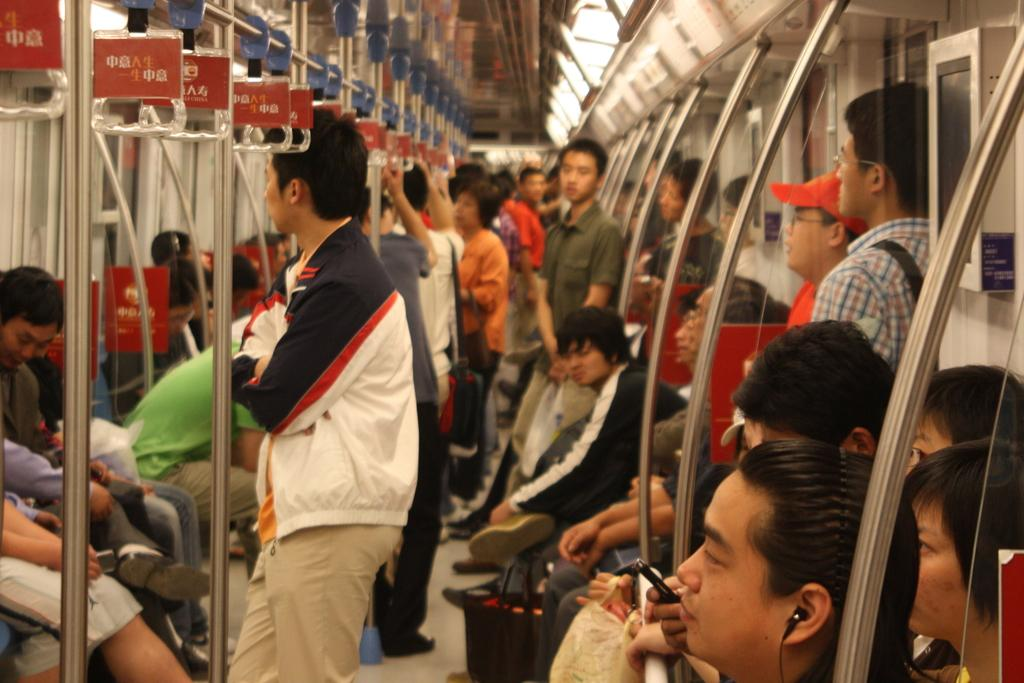How many people are in the image? There is a group of people in the image, but the exact number cannot be determined from the provided facts. What are the people doing in the image? Some people are sitting, while others are standing in the image. Where are the people located in the image? The people are on a platform in the image. What items can be seen in the image besides the people? There are bags, hangers, and earphones visible in the image. What type of vehicle is the image taken from? The image is an inside view of a vehicle. How many bubbles are floating around the people in the image? There are no bubbles present in the image. 